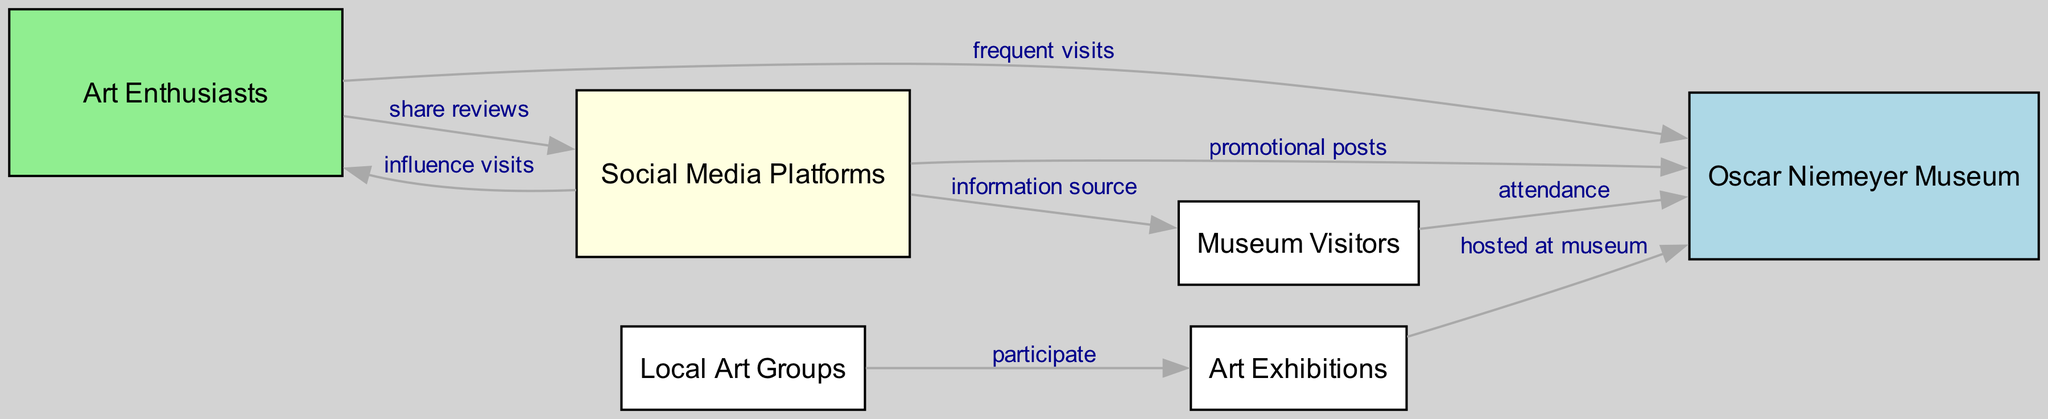What is the total number of nodes in the diagram? The nodes are the distinct entities represented, which include "Art Enthusiasts," "Oscar Niemeyer Museum," "Social Media Platforms," "Art Exhibitions," "Local Art Groups," and "Museum Visitors." Counting these, there are a total of six nodes in the diagram.
Answer: 6 Which node represents the museum in the diagram? The node labeled "Oscar Niemeyer Museum" directly indicates the museum being discussed in the diagram.
Answer: Oscar Niemeyer Museum What relationship exists between "Art Enthusiasts" and "Social Media Platforms"? The edge connecting "Art Enthusiasts" to "Social Media Platforms" is labeled "share reviews," which shows that art enthusiasts share their experiences on social media.
Answer: share reviews How many edges are connected to "Social Media Platforms"? By examining the edges, we see that "Social Media Platforms" connects to four other nodes: "Art Enthusiasts," "Oscar Niemeyer Museum," "Museum Visitors," and "Art Exhibitions." Therefore, it is connected to four edges.
Answer: 4 Which node participates in the exhibitions at the museum? "Local Art Groups" is the node that indicates participation in exhibitions at the Oscar Niemeyer Museum, as stated in the edge description.
Answer: Local Art Groups What is the primary influence of "Social Media Platforms" on "Museum Visitors"? The edge from "Social Media Platforms" to "Museum Visitors" indicates that it acts as an "information source," which means it provides information to potential visitors influencing their choice to visit the museum.
Answer: information source How do "Art Exhibitions" relate to the "Oscar Niemeyer Museum"? There is a direct connection labeled "hosted at museum," indicating that the Oscar Niemeyer Museum hosts various art exhibitions, establishing a relationship between the two nodes.
Answer: hosted at museum What effect do "Art Enthusiasts" have on the number of museum visitors? The edge labeled "frequent visits" from "Art Enthusiasts" to "Oscar Niemeyer Museum" implies that art enthusiasts have a regular impact on increasing the number of visitors to the museum.
Answer: frequent visits Which node influences art enthusiasts to visit museums based on social media? "Social Media Platforms" directly influences art enthusiasts, as indicated by the connection labeled "influence visits," which shows that social media reviews encourage art enthusiasts to visit museums.
Answer: Social Media Platforms 